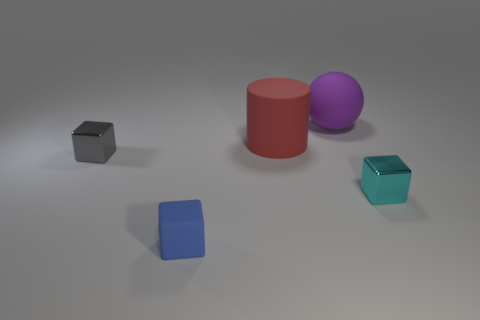The object that is behind the small gray block and right of the big red rubber thing is made of what material?
Provide a short and direct response. Rubber. There is a gray object that is the same size as the blue matte object; what shape is it?
Provide a succinct answer. Cube. The metal block behind the metallic thing that is in front of the tiny shiny object that is left of the red cylinder is what color?
Provide a succinct answer. Gray. What number of objects are shiny cubes in front of the purple thing or gray blocks?
Ensure brevity in your answer.  2. There is a red object that is the same size as the ball; what is its material?
Your answer should be compact. Rubber. The tiny thing that is on the right side of the small block in front of the block right of the purple rubber ball is made of what material?
Offer a very short reply. Metal. The large matte sphere is what color?
Provide a short and direct response. Purple. How many tiny things are either gray cubes or matte objects?
Ensure brevity in your answer.  2. Does the tiny cube behind the cyan shiny block have the same material as the small object to the right of the large purple object?
Make the answer very short. Yes. Is there a tiny blue thing?
Offer a terse response. Yes. 